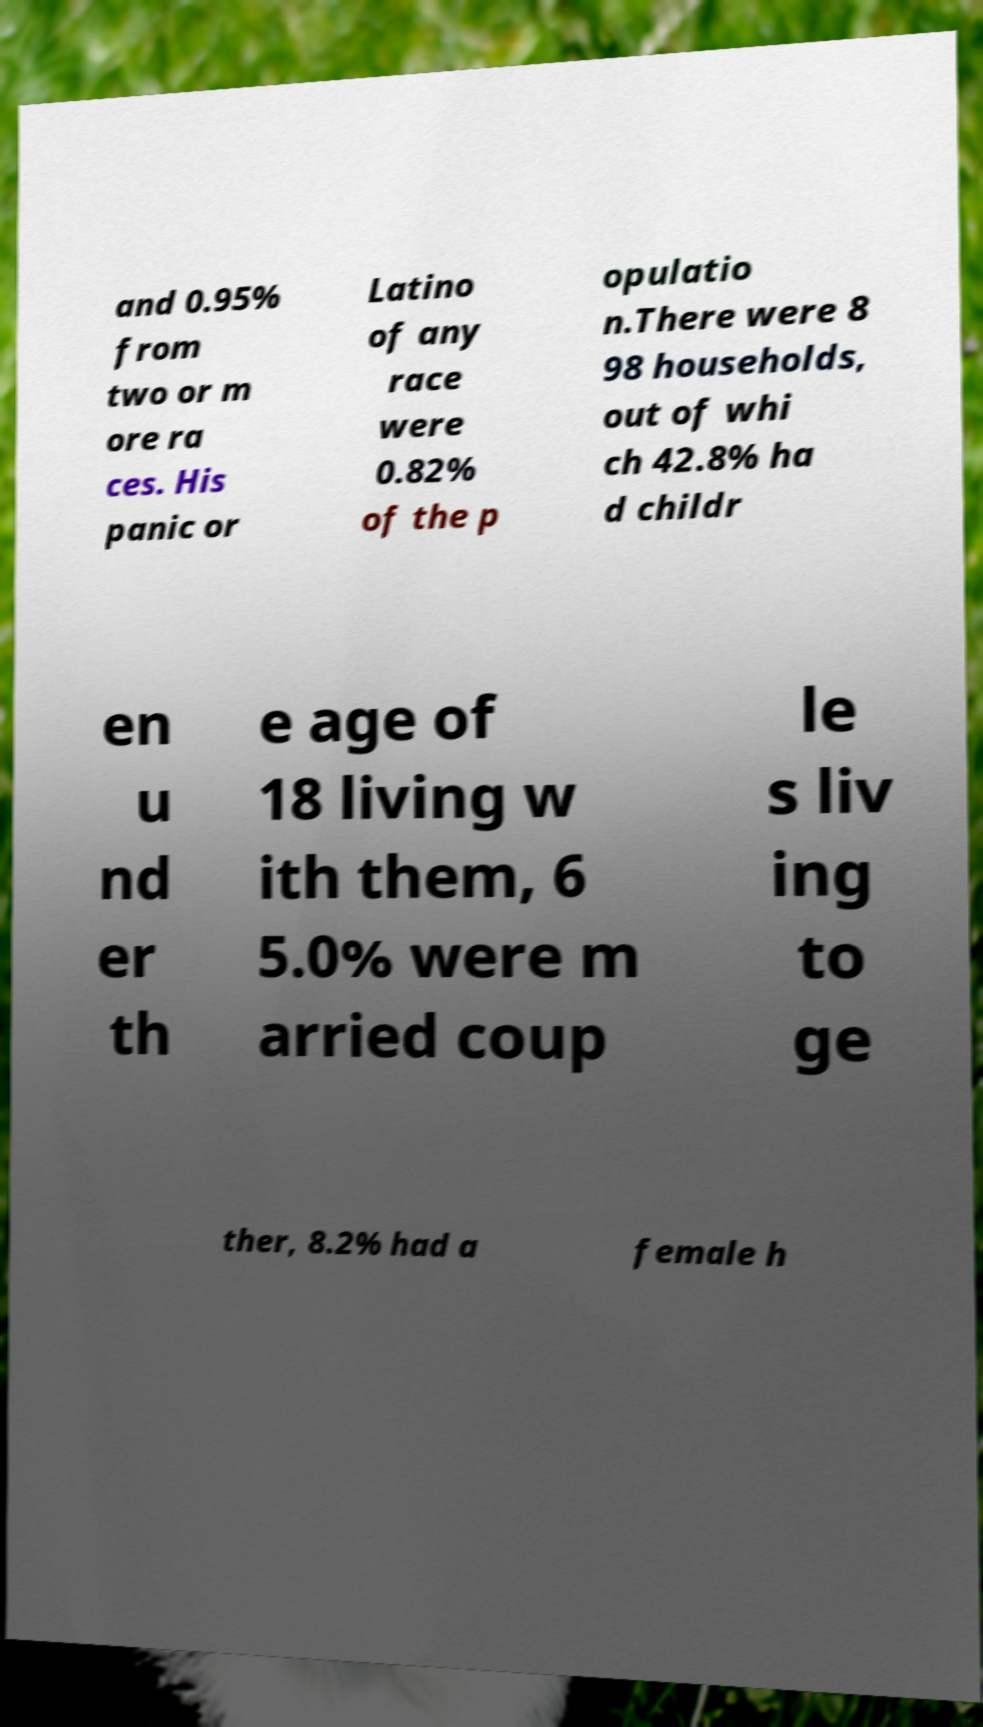Could you assist in decoding the text presented in this image and type it out clearly? and 0.95% from two or m ore ra ces. His panic or Latino of any race were 0.82% of the p opulatio n.There were 8 98 households, out of whi ch 42.8% ha d childr en u nd er th e age of 18 living w ith them, 6 5.0% were m arried coup le s liv ing to ge ther, 8.2% had a female h 